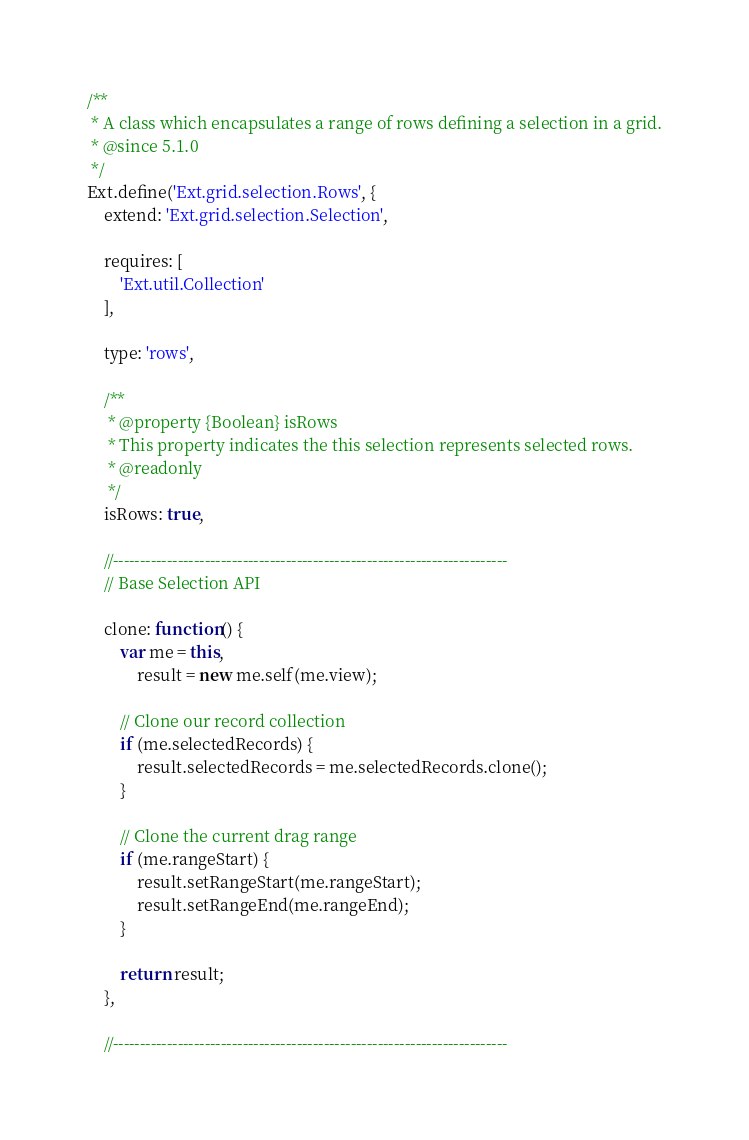<code> <loc_0><loc_0><loc_500><loc_500><_JavaScript_>/**
 * A class which encapsulates a range of rows defining a selection in a grid.
 * @since 5.1.0
 */
Ext.define('Ext.grid.selection.Rows', {
    extend: 'Ext.grid.selection.Selection',

    requires: [
        'Ext.util.Collection'
    ],

    type: 'rows',

    /**
     * @property {Boolean} isRows
     * This property indicates the this selection represents selected rows.
     * @readonly
     */
    isRows: true,

    //-------------------------------------------------------------------------
    // Base Selection API

    clone: function() {
        var me = this,
            result = new me.self(me.view);

        // Clone our record collection
        if (me.selectedRecords) {
            result.selectedRecords = me.selectedRecords.clone();
        }

        // Clone the current drag range
        if (me.rangeStart) {
            result.setRangeStart(me.rangeStart);
            result.setRangeEnd(me.rangeEnd);
        }

        return result;
    },

    //-------------------------------------------------------------------------</code> 